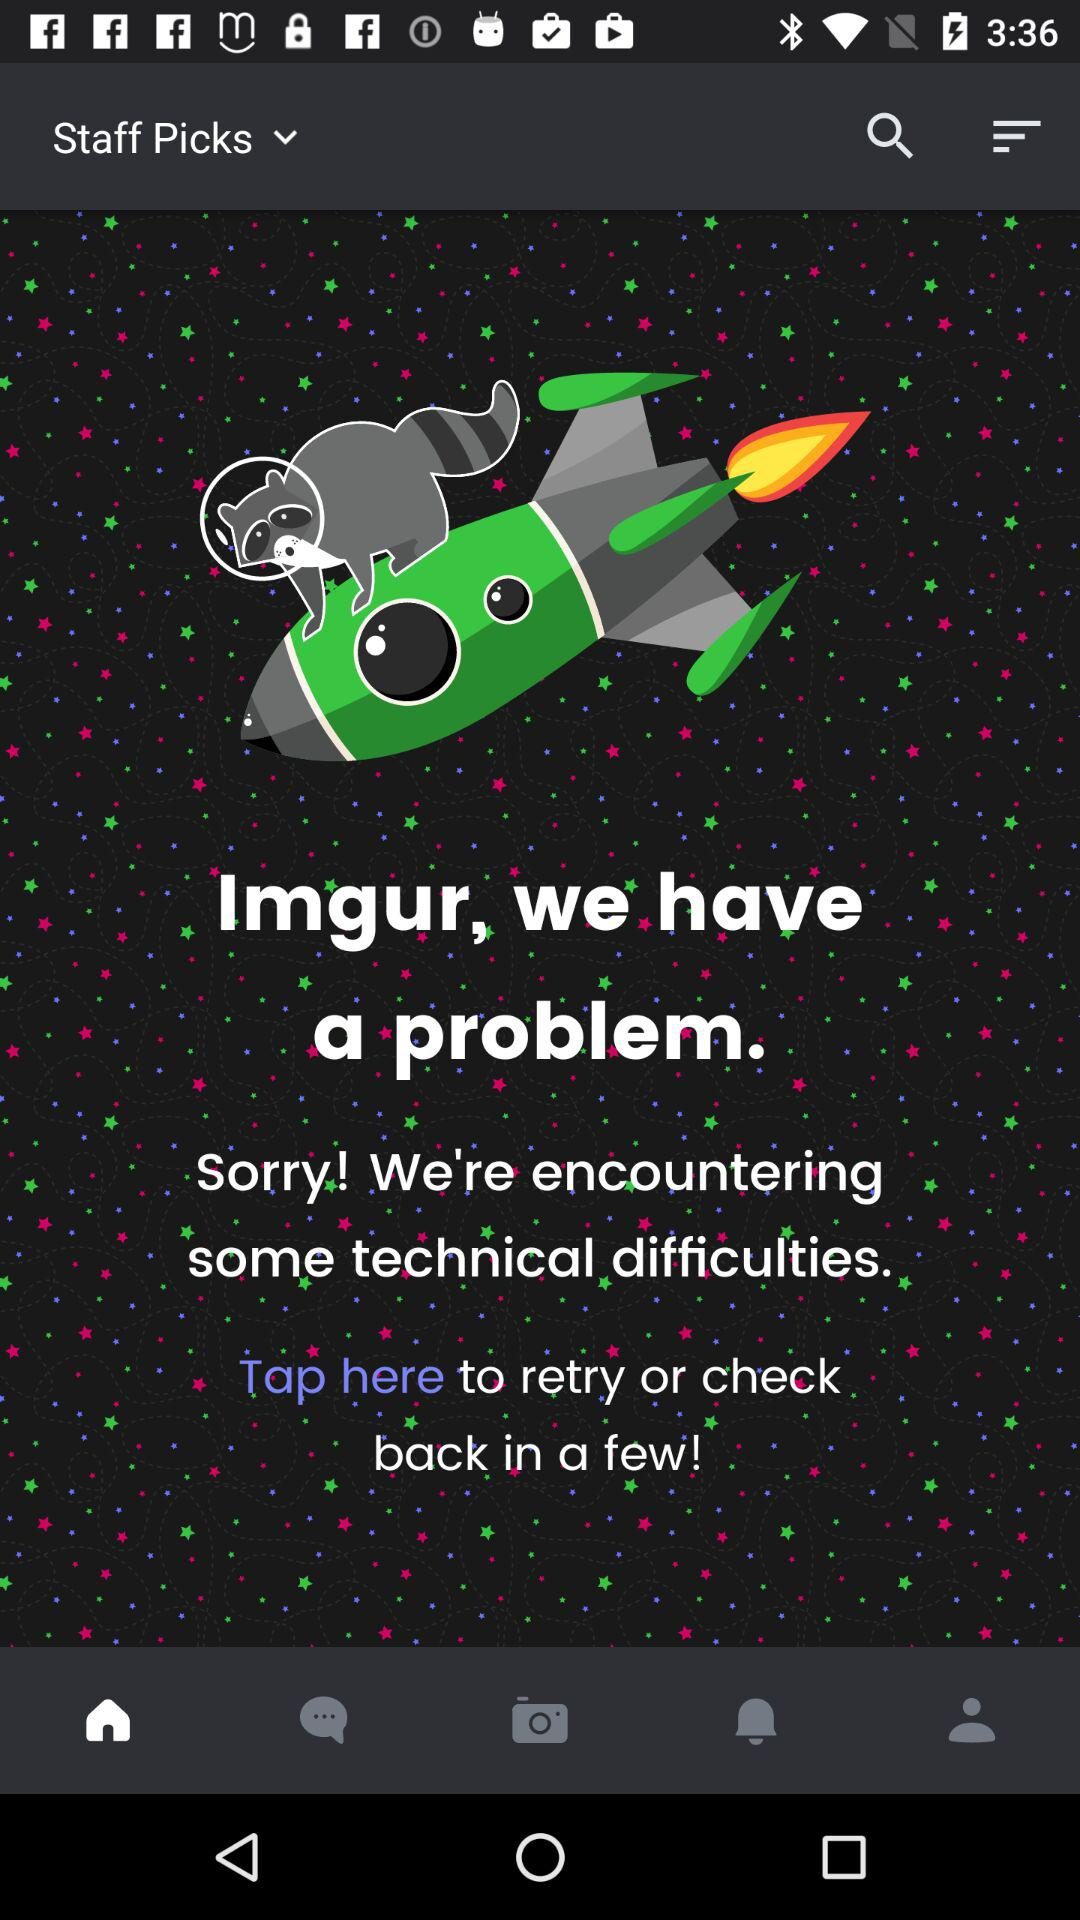Which items are in the staff picks drop-down menu?
When the provided information is insufficient, respond with <no answer>. <no answer> 